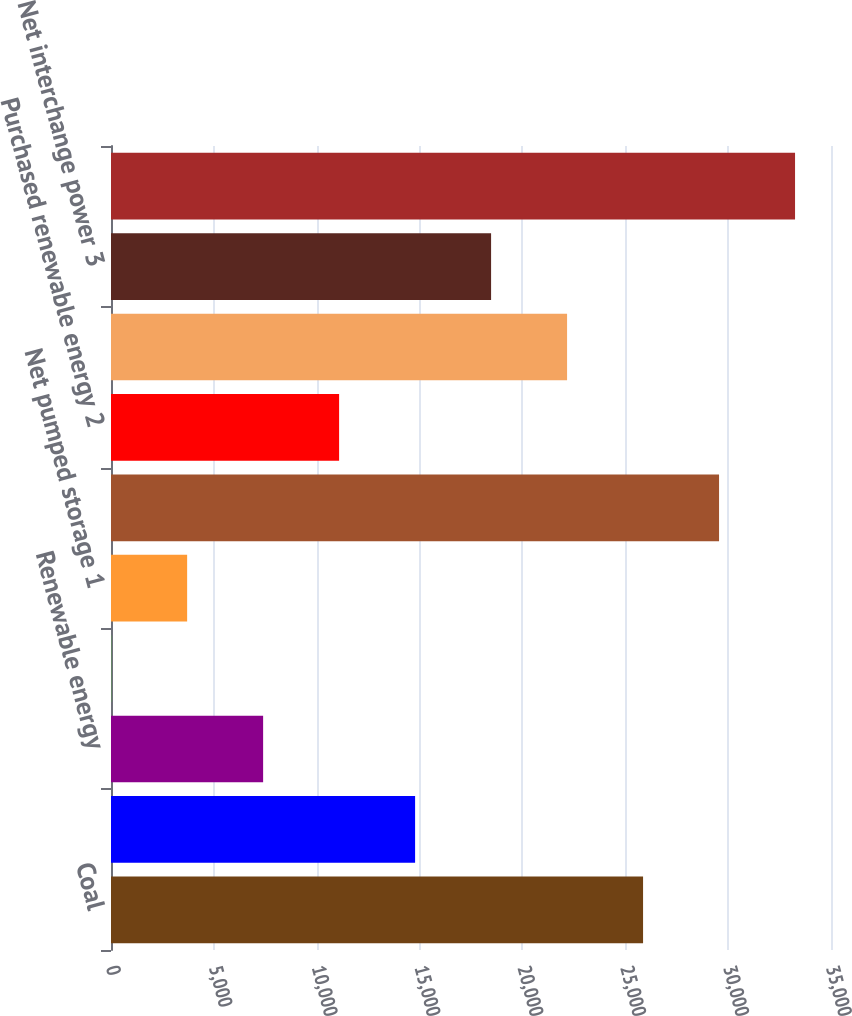Convert chart. <chart><loc_0><loc_0><loc_500><loc_500><bar_chart><fcel>Coal<fcel>Gas<fcel>Renewable energy<fcel>Oil<fcel>Net pumped storage 1<fcel>Total owned generation<fcel>Purchased renewable energy 2<fcel>Purchased generation - other 2<fcel>Net interchange power 3<fcel>Total purchased and<nl><fcel>25864.3<fcel>14782.6<fcel>7394.8<fcel>7<fcel>3700.9<fcel>29558.2<fcel>11088.7<fcel>22170.4<fcel>18476.5<fcel>33252.1<nl></chart> 